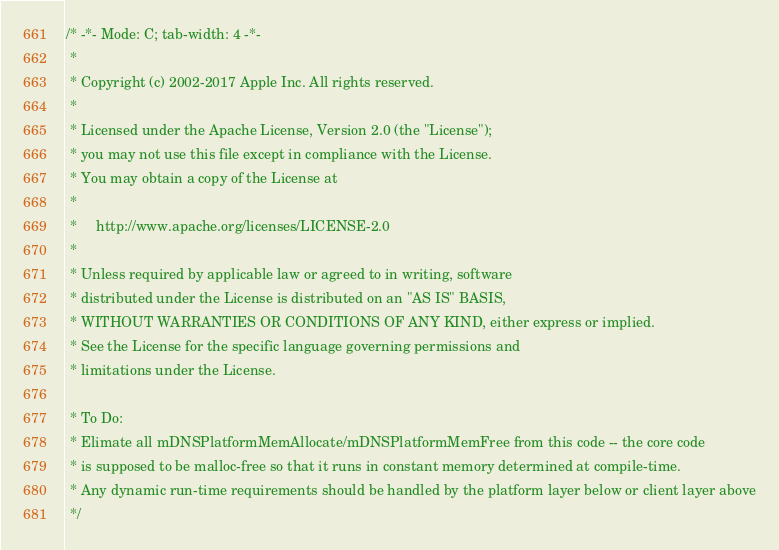Convert code to text. <code><loc_0><loc_0><loc_500><loc_500><_C_>/* -*- Mode: C; tab-width: 4 -*-
 *
 * Copyright (c) 2002-2017 Apple Inc. All rights reserved.
 *
 * Licensed under the Apache License, Version 2.0 (the "License");
 * you may not use this file except in compliance with the License.
 * You may obtain a copy of the License at
 *
 *     http://www.apache.org/licenses/LICENSE-2.0
 *
 * Unless required by applicable law or agreed to in writing, software
 * distributed under the License is distributed on an "AS IS" BASIS,
 * WITHOUT WARRANTIES OR CONDITIONS OF ANY KIND, either express or implied.
 * See the License for the specific language governing permissions and
 * limitations under the License.

 * To Do:
 * Elimate all mDNSPlatformMemAllocate/mDNSPlatformMemFree from this code -- the core code
 * is supposed to be malloc-free so that it runs in constant memory determined at compile-time.
 * Any dynamic run-time requirements should be handled by the platform layer below or client layer above
 */
</code> 